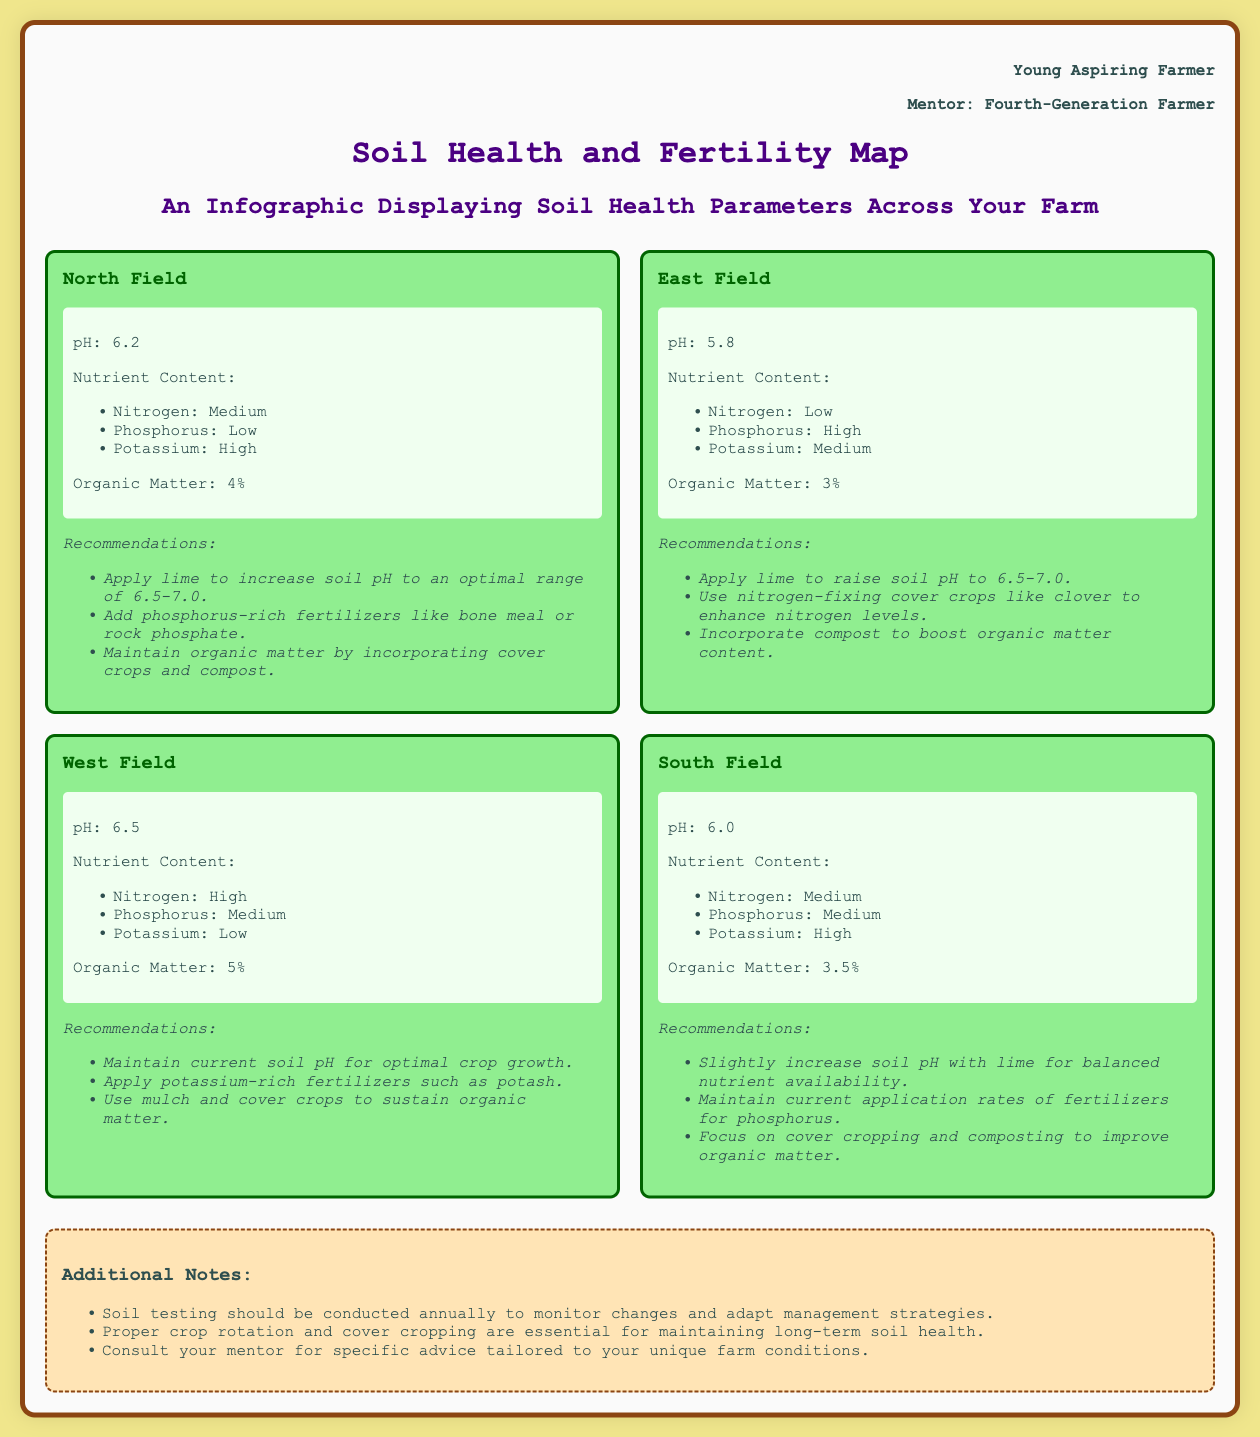what is the pH of the North Field? The pH of the North Field is stated directly in the document as 6.2.
Answer: 6.2 what is the nutrient content of the East Field in terms of nitrogen? The document specifies that the nitrogen content in the East Field is low.
Answer: Low which field has the highest organic matter percentage? The West Field has an organic matter percentage of 5%, which is the highest among all fields.
Answer: 5% what is the primary recommendation for the South Field? The primary recommendation for the South Field is to slightly increase soil pH with lime for balanced nutrient availability.
Answer: Slightly increase soil pH with lime which nutrient is low in the North Field? The document indicates that the phosphorus nutrient is low in the North Field.
Answer: Phosphorus what should be applied to the West Field to address low potassium levels? The recommendation states that potassium-rich fertilizers such as potash should be applied to the West Field.
Answer: Potassium-rich fertilizers like potash how often should soil testing be conducted? The document notes that soil testing should be conducted annually.
Answer: Annually what is an essential practice for maintaining long-term soil health? The document emphasizes that proper crop rotation is essential for maintaining long-term soil health.
Answer: Proper crop rotation 